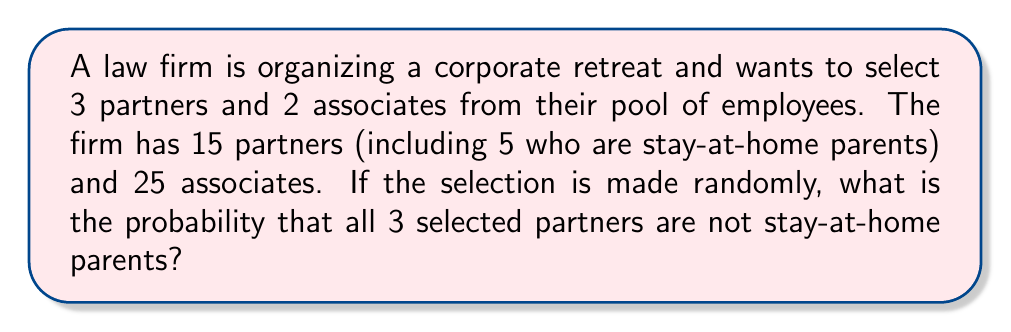Provide a solution to this math problem. Let's approach this step-by-step:

1) First, we need to calculate the total number of ways to select 3 partners and 2 associates. This can be done using the combination formula:

   $$\binom{15}{3} \times \binom{25}{2}$$

2) Now, we need to calculate the number of ways to select 3 partners who are not stay-at-home parents. There are 10 such partners (15 total - 5 stay-at-home), so this is:

   $$\binom{10}{3}$$

3) The number of ways to select 2 associates remains the same:

   $$\binom{25}{2}$$

4) So, the number of favorable outcomes (selecting 3 non-stay-at-home partners and 2 associates) is:

   $$\binom{10}{3} \times \binom{25}{2}$$

5) The probability is the number of favorable outcomes divided by the total number of possible outcomes:

   $$P = \frac{\binom{10}{3} \times \binom{25}{2}}{\binom{15}{3} \times \binom{25}{2}}$$

6) The $\binom{25}{2}$ cancels out in the numerator and denominator:

   $$P = \frac{\binom{10}{3}}{\binom{15}{3}}$$

7) Let's calculate these values:
   
   $$\binom{10}{3} = \frac{10!}{3!(10-3)!} = \frac{10!}{3!7!} = 120$$
   
   $$\binom{15}{3} = \frac{15!}{3!(15-3)!} = \frac{15!}{3!12!} = 455$$

8) Therefore, the probability is:

   $$P = \frac{120}{455} = \frac{24}{91} \approx 0.2637$$
Answer: $\frac{24}{91}$ or approximately $0.2637$ or $26.37\%$ 